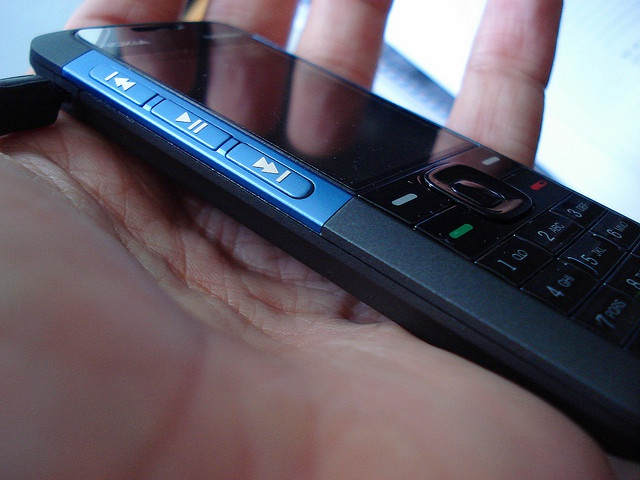Describe the objects in this image and their specific colors. I can see people in lightblue, gray, and black tones and cell phone in lightblue, black, navy, and gray tones in this image. 